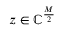<formula> <loc_0><loc_0><loc_500><loc_500>z \in \mathbb { C } ^ { \frac { M } { 2 } }</formula> 